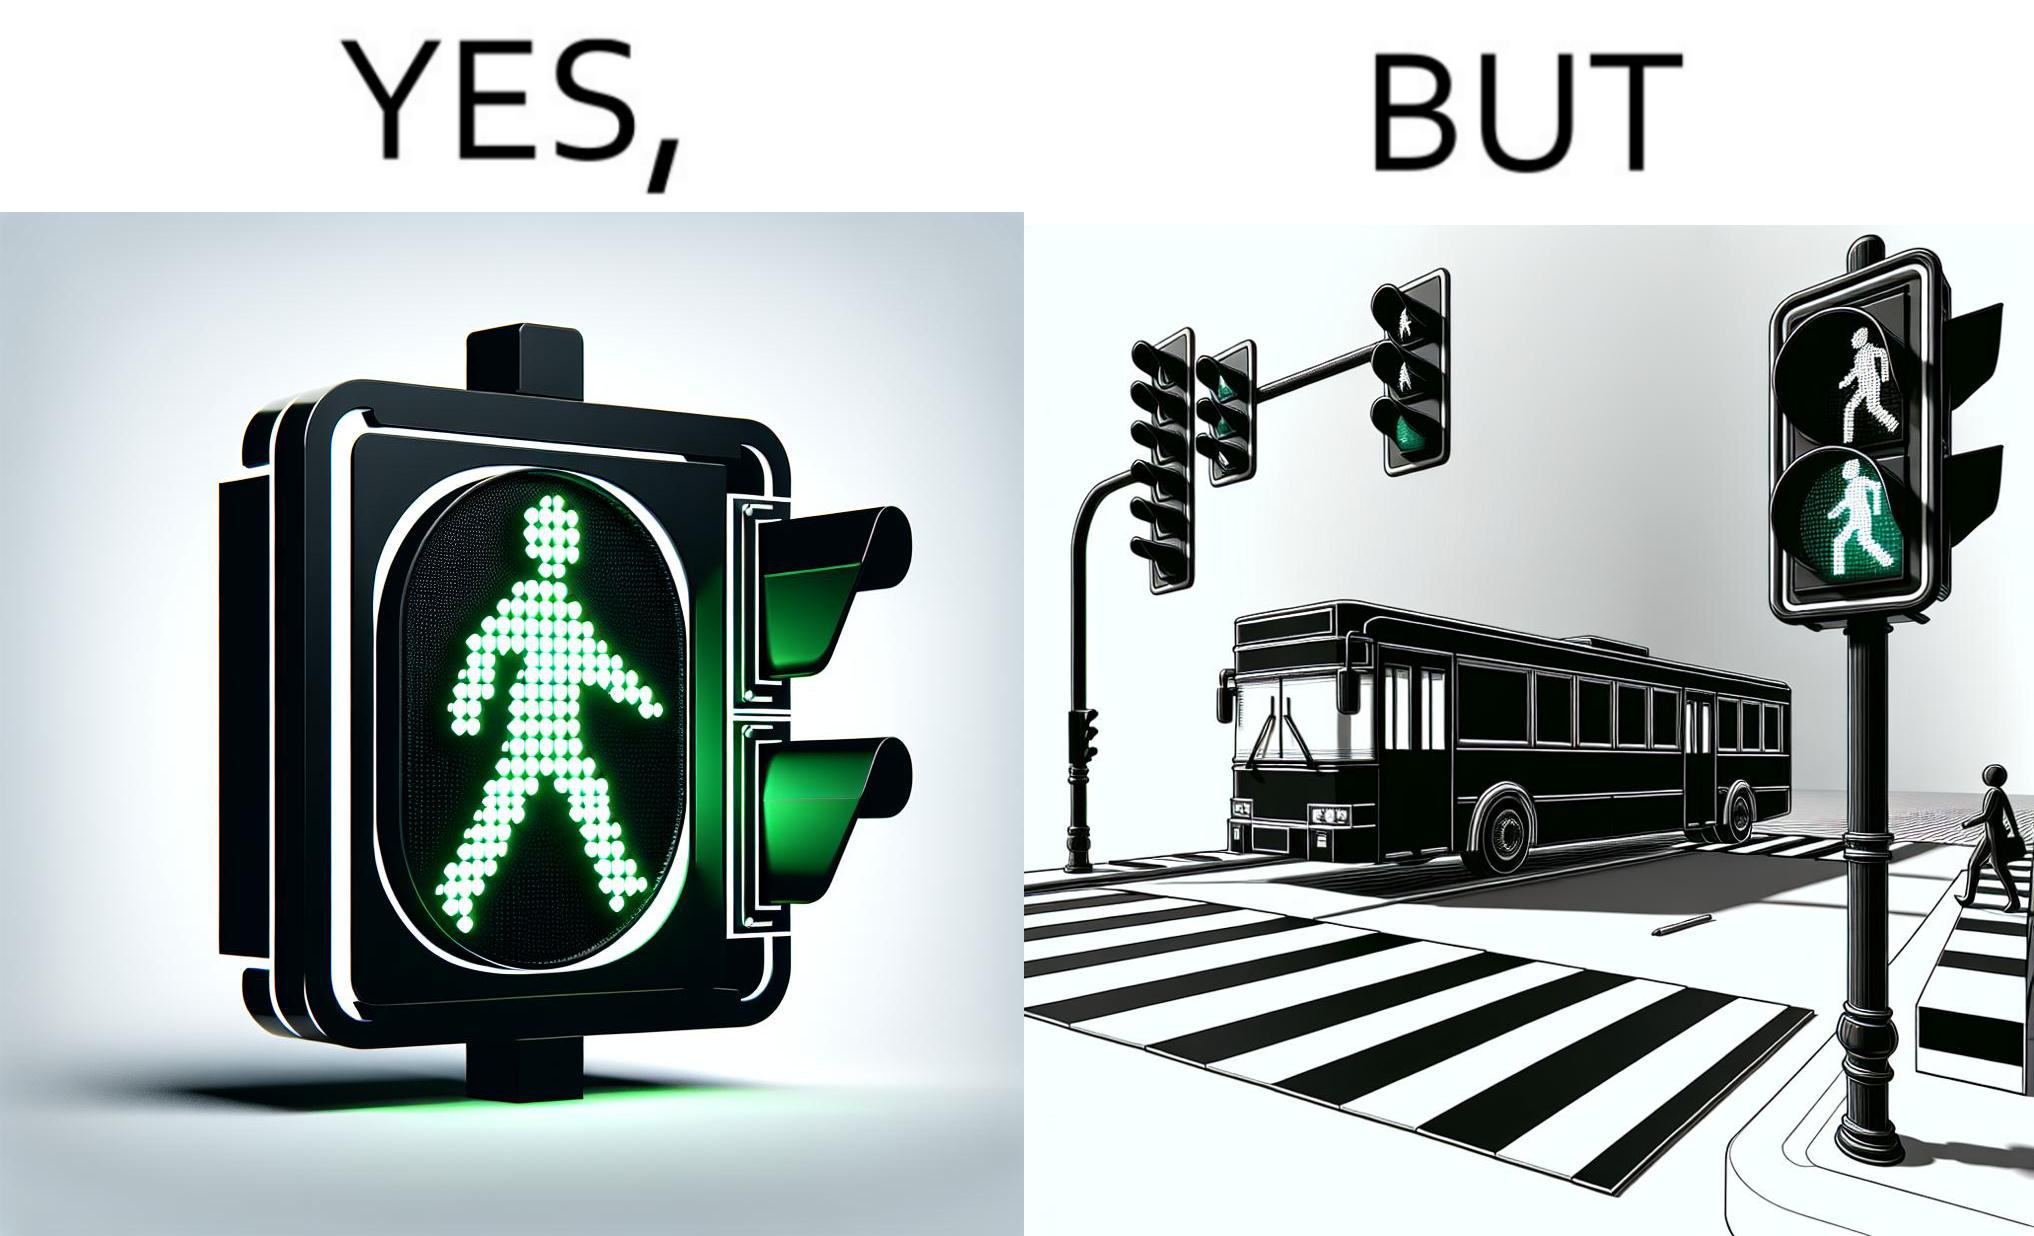Provide a description of this image. The image is ironic, because even when the signal is green for the pedestrians but they can't cross the road because of the vehicles standing on the zebra crossing 